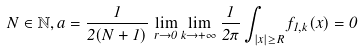<formula> <loc_0><loc_0><loc_500><loc_500>N \in \mathbb { N } , a = \frac { 1 } { 2 ( N + 1 ) } \, \lim _ { r \to 0 } \lim _ { k \to + \infty } \frac { 1 } { 2 \pi } \int _ { | x | \geq R } f _ { 1 , k } ( x ) = 0</formula> 